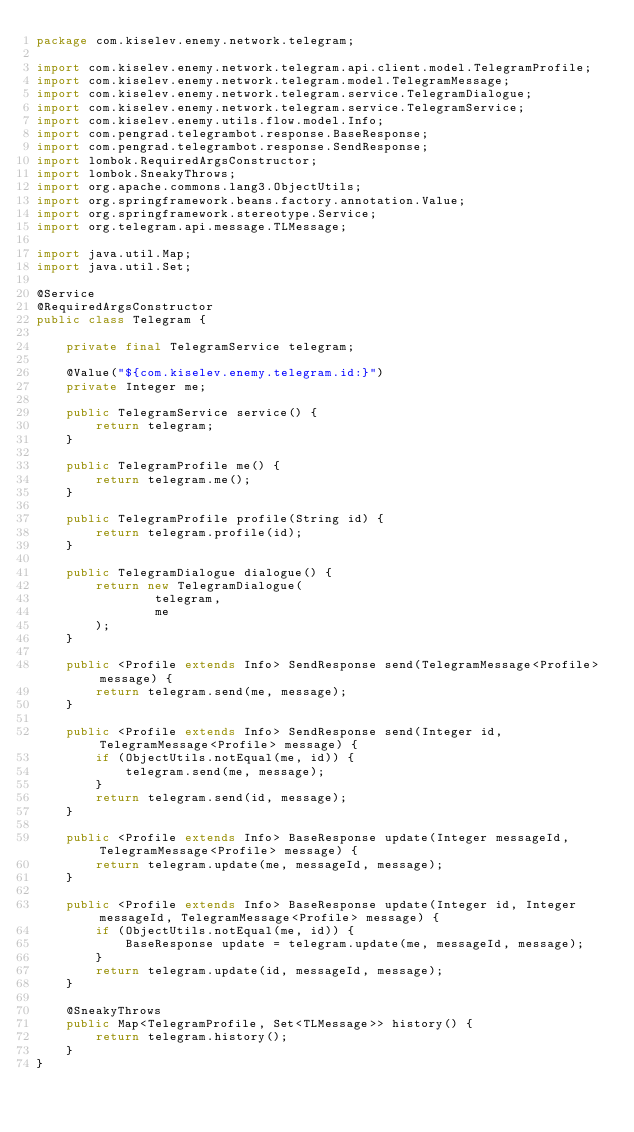Convert code to text. <code><loc_0><loc_0><loc_500><loc_500><_Java_>package com.kiselev.enemy.network.telegram;

import com.kiselev.enemy.network.telegram.api.client.model.TelegramProfile;
import com.kiselev.enemy.network.telegram.model.TelegramMessage;
import com.kiselev.enemy.network.telegram.service.TelegramDialogue;
import com.kiselev.enemy.network.telegram.service.TelegramService;
import com.kiselev.enemy.utils.flow.model.Info;
import com.pengrad.telegrambot.response.BaseResponse;
import com.pengrad.telegrambot.response.SendResponse;
import lombok.RequiredArgsConstructor;
import lombok.SneakyThrows;
import org.apache.commons.lang3.ObjectUtils;
import org.springframework.beans.factory.annotation.Value;
import org.springframework.stereotype.Service;
import org.telegram.api.message.TLMessage;

import java.util.Map;
import java.util.Set;

@Service
@RequiredArgsConstructor
public class Telegram {

    private final TelegramService telegram;

    @Value("${com.kiselev.enemy.telegram.id:}")
    private Integer me;

    public TelegramService service() {
        return telegram;
    }

    public TelegramProfile me() {
        return telegram.me();
    }

    public TelegramProfile profile(String id) {
        return telegram.profile(id);
    }

    public TelegramDialogue dialogue() {
        return new TelegramDialogue(
                telegram,
                me
        );
    }

    public <Profile extends Info> SendResponse send(TelegramMessage<Profile> message) {
        return telegram.send(me, message);
    }

    public <Profile extends Info> SendResponse send(Integer id, TelegramMessage<Profile> message) {
        if (ObjectUtils.notEqual(me, id)) {
            telegram.send(me, message);
        }
        return telegram.send(id, message);
    }

    public <Profile extends Info> BaseResponse update(Integer messageId, TelegramMessage<Profile> message) {
        return telegram.update(me, messageId, message);
    }

    public <Profile extends Info> BaseResponse update(Integer id, Integer messageId, TelegramMessage<Profile> message) {
        if (ObjectUtils.notEqual(me, id)) {
            BaseResponse update = telegram.update(me, messageId, message);
        }
        return telegram.update(id, messageId, message);
    }

    @SneakyThrows
    public Map<TelegramProfile, Set<TLMessage>> history() {
        return telegram.history();
    }
}
</code> 